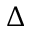<formula> <loc_0><loc_0><loc_500><loc_500>\Delta</formula> 